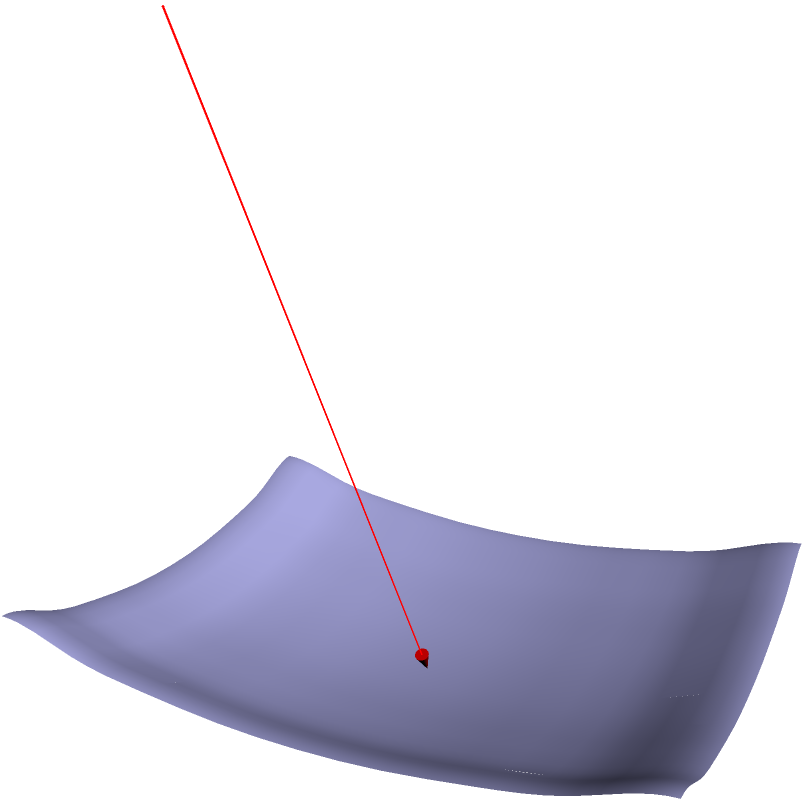A parabolic solar dish is modeled by the equation $z = 0.1(x^2 + y^2)$. A ray of sunlight is represented by the vector equation $\mathbf{r}(t) = (3,0,5) + t(-3,0,-5)$, where $t$ is a parameter. At what point does this ray intersect the parabolic dish? To solve this problem, we'll follow these steps:

1) The parabolic dish is given by the equation:
   $$z = 0.1(x^2 + y^2)$$

2) The ray of sunlight is represented by the parametric equations:
   $$x = 3 - 3t$$
   $$y = 0$$
   $$z = 5 - 5t$$

3) At the intersection point, the z-coordinate of the ray must equal the z-coordinate of the dish. So we can set up the equation:
   $$5 - 5t = 0.1((3-3t)^2 + 0^2)$$

4) Simplify the right side:
   $$5 - 5t = 0.1(9-18t+9t^2)$$

5) Multiply both sides by 10:
   $$50 - 50t = 9-18t+9t^2$$

6) Rearrange to standard form:
   $$9t^2 - 32t - 41 = 0$$

7) This is a quadratic equation. We can solve it using the quadratic formula:
   $$t = \frac{-b \pm \sqrt{b^2 - 4ac}}{2a}$$
   where $a=9$, $b=-32$, and $c=-41$

8) Plugging in these values:
   $$t = \frac{32 \pm \sqrt{(-32)^2 - 4(9)(-41)}}{2(9)}$$
   $$t = \frac{32 \pm \sqrt{1024 + 1476}}{18}$$
   $$t = \frac{32 \pm \sqrt{2500}}{18}$$
   $$t = \frac{32 \pm 50}{18}$$

9) This gives us two solutions:
   $$t_1 = \frac{82}{18} \approx 4.56$$
   $$t_2 = -\frac{18}{18} = -1$$

10) The negative value of $t$ corresponds to a point behind the starting point of the ray, so we use $t_1$.

11) Substitute this value back into the parametric equations:
    $$x = 3 - 3(4.56) = -10.68$$
    $$y = 0$$
    $$z = 5 - 5(4.56) = -17.8$$

Therefore, the ray intersects the dish at the point $(-10.68, 0, -17.8)$.
Answer: $(-10.68, 0, -17.8)$ 